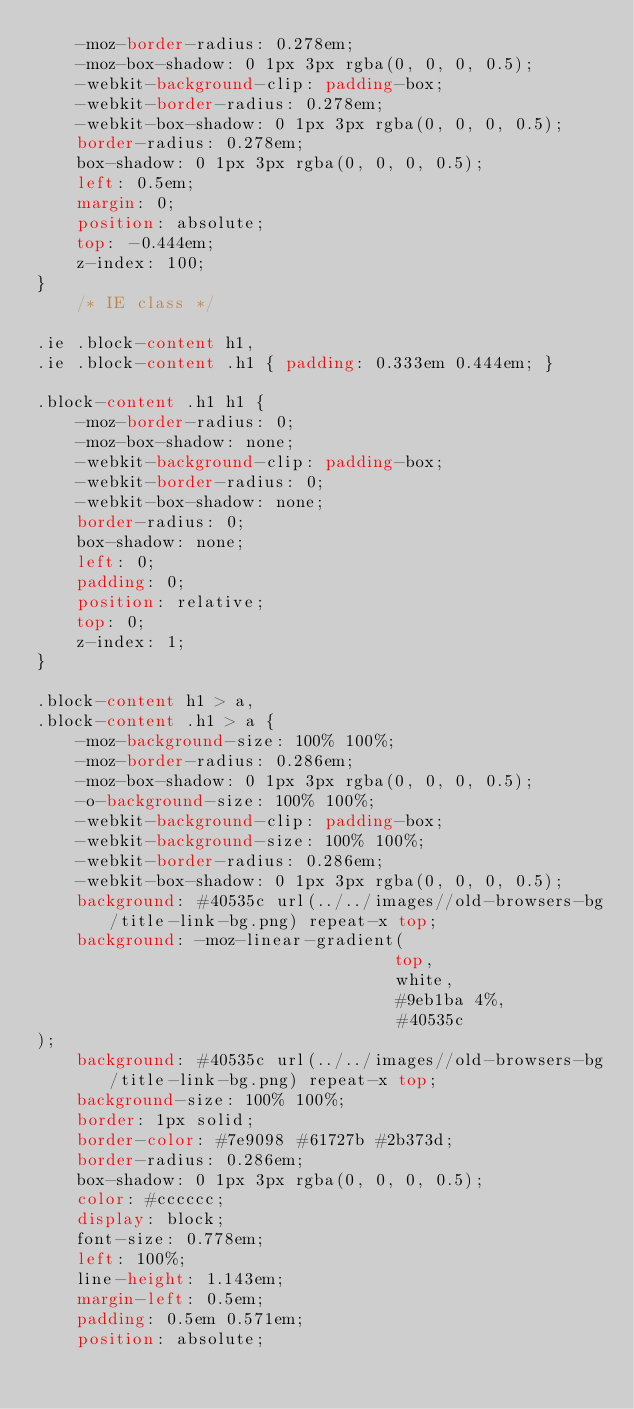<code> <loc_0><loc_0><loc_500><loc_500><_CSS_>	-moz-border-radius: 0.278em;
	-moz-box-shadow: 0 1px 3px rgba(0, 0, 0, 0.5);
	-webkit-background-clip: padding-box;
	-webkit-border-radius: 0.278em;
	-webkit-box-shadow: 0 1px 3px rgba(0, 0, 0, 0.5);
	border-radius: 0.278em;
	box-shadow: 0 1px 3px rgba(0, 0, 0, 0.5);
	left: 0.5em;
	margin: 0;
	position: absolute;
	top: -0.444em;
	z-index: 100;
}
	/* IE class */

.ie .block-content h1,
.ie .block-content .h1 { padding: 0.333em 0.444em; }

.block-content .h1 h1 {
	-moz-border-radius: 0;
	-moz-box-shadow: none;
	-webkit-background-clip: padding-box;
	-webkit-border-radius: 0;
	-webkit-box-shadow: none;
	border-radius: 0;
	box-shadow: none;
	left: 0;
	padding: 0;
	position: relative;
	top: 0;
	z-index: 1;
}

.block-content h1 > a,
.block-content .h1 > a {
	-moz-background-size: 100% 100%;
	-moz-border-radius: 0.286em;
	-moz-box-shadow: 0 1px 3px rgba(0, 0, 0, 0.5);
	-o-background-size: 100% 100%;
	-webkit-background-clip: padding-box;
	-webkit-background-size: 100% 100%;
	-webkit-border-radius: 0.286em;
	-webkit-box-shadow: 0 1px 3px rgba(0, 0, 0, 0.5);
	background: #40535c url(../../images//old-browsers-bg/title-link-bg.png) repeat-x top;
	background: -moz-linear-gradient(
	                                top,
	                                white,
	                                #9eb1ba 4%,
	                                #40535c
);
	background: #40535c url(../../images//old-browsers-bg/title-link-bg.png) repeat-x top;
	background-size: 100% 100%;
	border: 1px solid;
	border-color: #7e9098 #61727b #2b373d;
	border-radius: 0.286em;
	box-shadow: 0 1px 3px rgba(0, 0, 0, 0.5);
	color: #cccccc;
	display: block;
	font-size: 0.778em;
	left: 100%;
	line-height: 1.143em;
	margin-left: 0.5em;
	padding: 0.5em 0.571em;
	position: absolute;</code> 